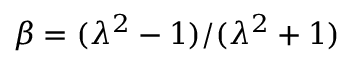<formula> <loc_0><loc_0><loc_500><loc_500>\beta = ( \lambda ^ { 2 } - 1 ) / ( \lambda ^ { 2 } + 1 )</formula> 